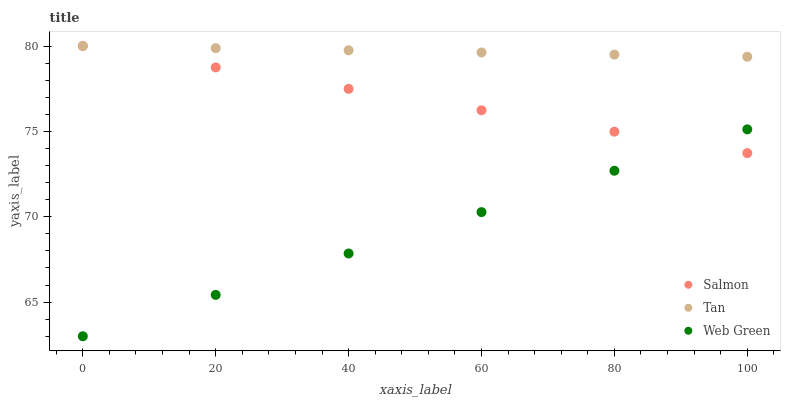Does Web Green have the minimum area under the curve?
Answer yes or no. Yes. Does Tan have the maximum area under the curve?
Answer yes or no. Yes. Does Salmon have the minimum area under the curve?
Answer yes or no. No. Does Salmon have the maximum area under the curve?
Answer yes or no. No. Is Salmon the smoothest?
Answer yes or no. Yes. Is Tan the roughest?
Answer yes or no. Yes. Is Web Green the smoothest?
Answer yes or no. No. Is Web Green the roughest?
Answer yes or no. No. Does Web Green have the lowest value?
Answer yes or no. Yes. Does Salmon have the lowest value?
Answer yes or no. No. Does Salmon have the highest value?
Answer yes or no. Yes. Does Web Green have the highest value?
Answer yes or no. No. Is Web Green less than Tan?
Answer yes or no. Yes. Is Tan greater than Web Green?
Answer yes or no. Yes. Does Web Green intersect Salmon?
Answer yes or no. Yes. Is Web Green less than Salmon?
Answer yes or no. No. Is Web Green greater than Salmon?
Answer yes or no. No. Does Web Green intersect Tan?
Answer yes or no. No. 